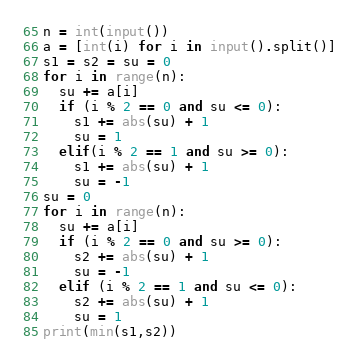<code> <loc_0><loc_0><loc_500><loc_500><_Python_>n = int(input())
a = [int(i) for i in input().split()]
s1 = s2 = su = 0
for i in range(n):
  su += a[i]
  if (i % 2 == 0 and su <= 0):
    s1 += abs(su) + 1
    su = 1
  elif(i % 2 == 1 and su >= 0):
    s1 += abs(su) + 1
    su = -1
su = 0
for i in range(n):
  su += a[i]
  if (i % 2 == 0 and su >= 0):
    s2 += abs(su) + 1
    su = -1
  elif (i % 2 == 1 and su <= 0):
    s2 += abs(su) + 1
    su = 1
print(min(s1,s2))</code> 